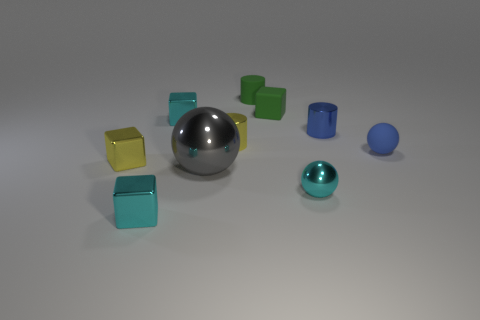What number of shiny things are the same color as the small metallic ball?
Keep it short and to the point. 2. Is the shape of the large gray thing the same as the tiny blue rubber object?
Provide a succinct answer. Yes. There is a metallic cylinder on the left side of the thing behind the rubber block; what is its size?
Keep it short and to the point. Small. Are there any matte objects of the same size as the gray ball?
Your response must be concise. No. There is a cyan thing that is behind the large gray sphere; is it the same size as the green object that is to the left of the tiny green matte block?
Provide a short and direct response. Yes. What shape is the cyan shiny thing on the right side of the tiny cylinder left of the rubber cylinder?
Your answer should be compact. Sphere. What number of tiny metal objects are right of the tiny yellow cylinder?
Give a very brief answer. 2. There is a small sphere that is the same material as the large gray thing; what is its color?
Keep it short and to the point. Cyan. Is the size of the blue matte ball the same as the cube on the right side of the tiny matte cylinder?
Make the answer very short. Yes. How big is the cyan block that is behind the blue thing right of the blue thing that is behind the blue matte object?
Provide a succinct answer. Small. 